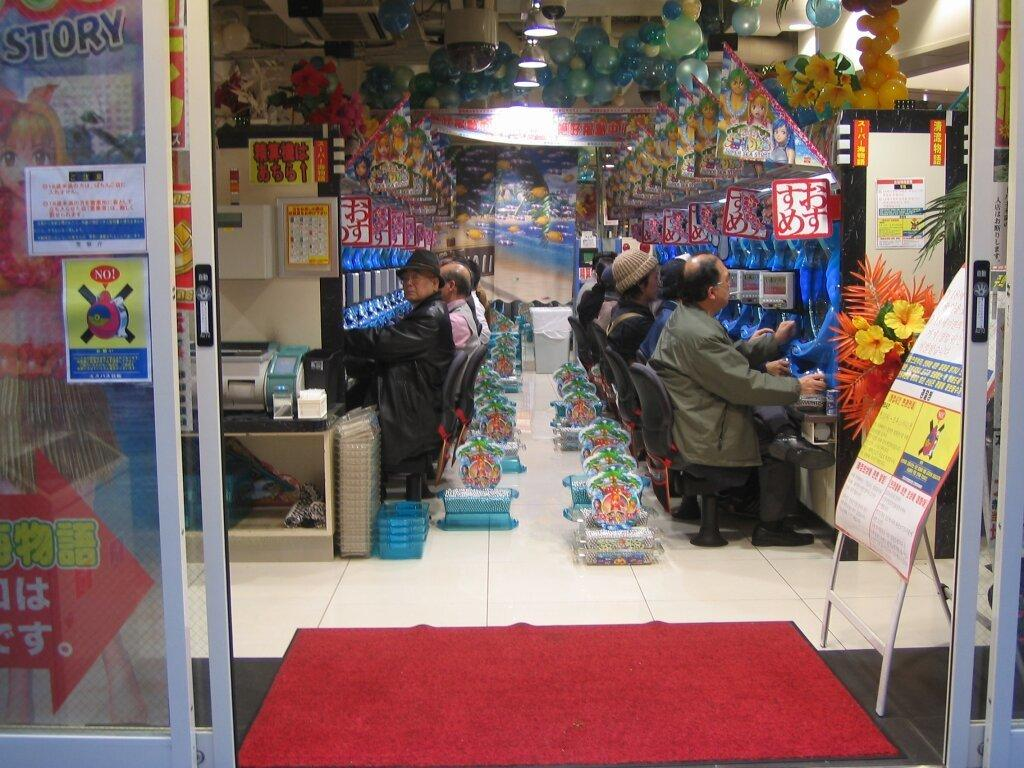<image>
Provide a brief description of the given image. Story is written on the glass doors of a building. 